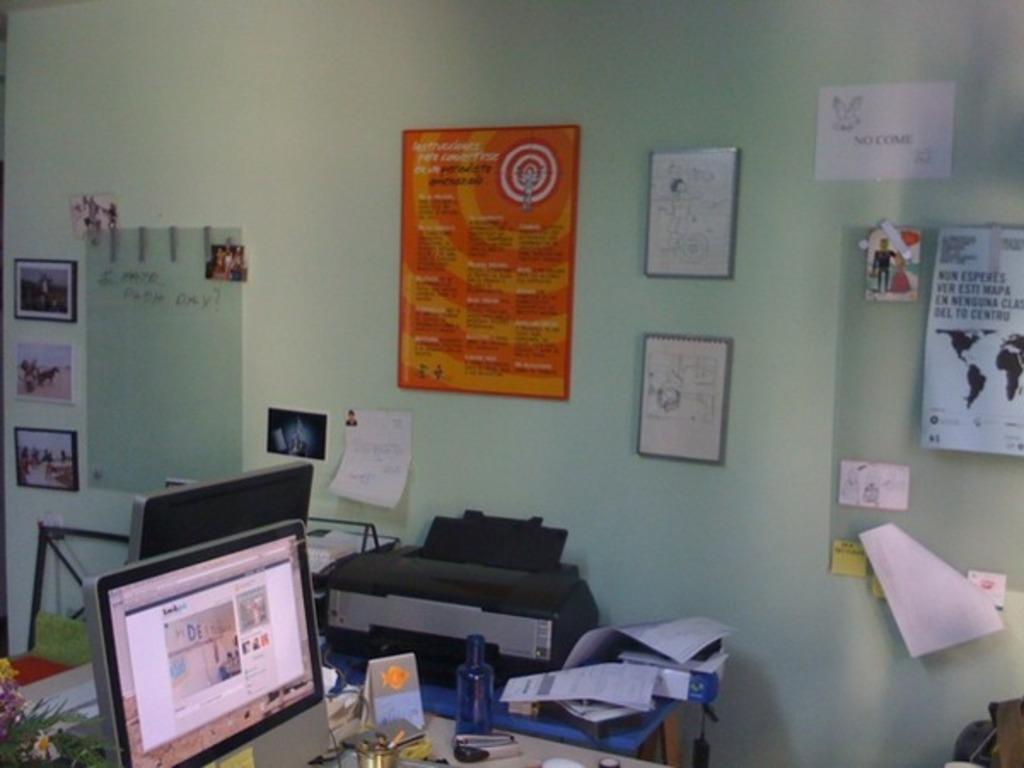Can you describe this image briefly? In this image I can see the systems, plants, electronic gadget, papers, bottles and some objects. These are on the surface. In the background I can see the papers, frames and boards attached to the wall. 